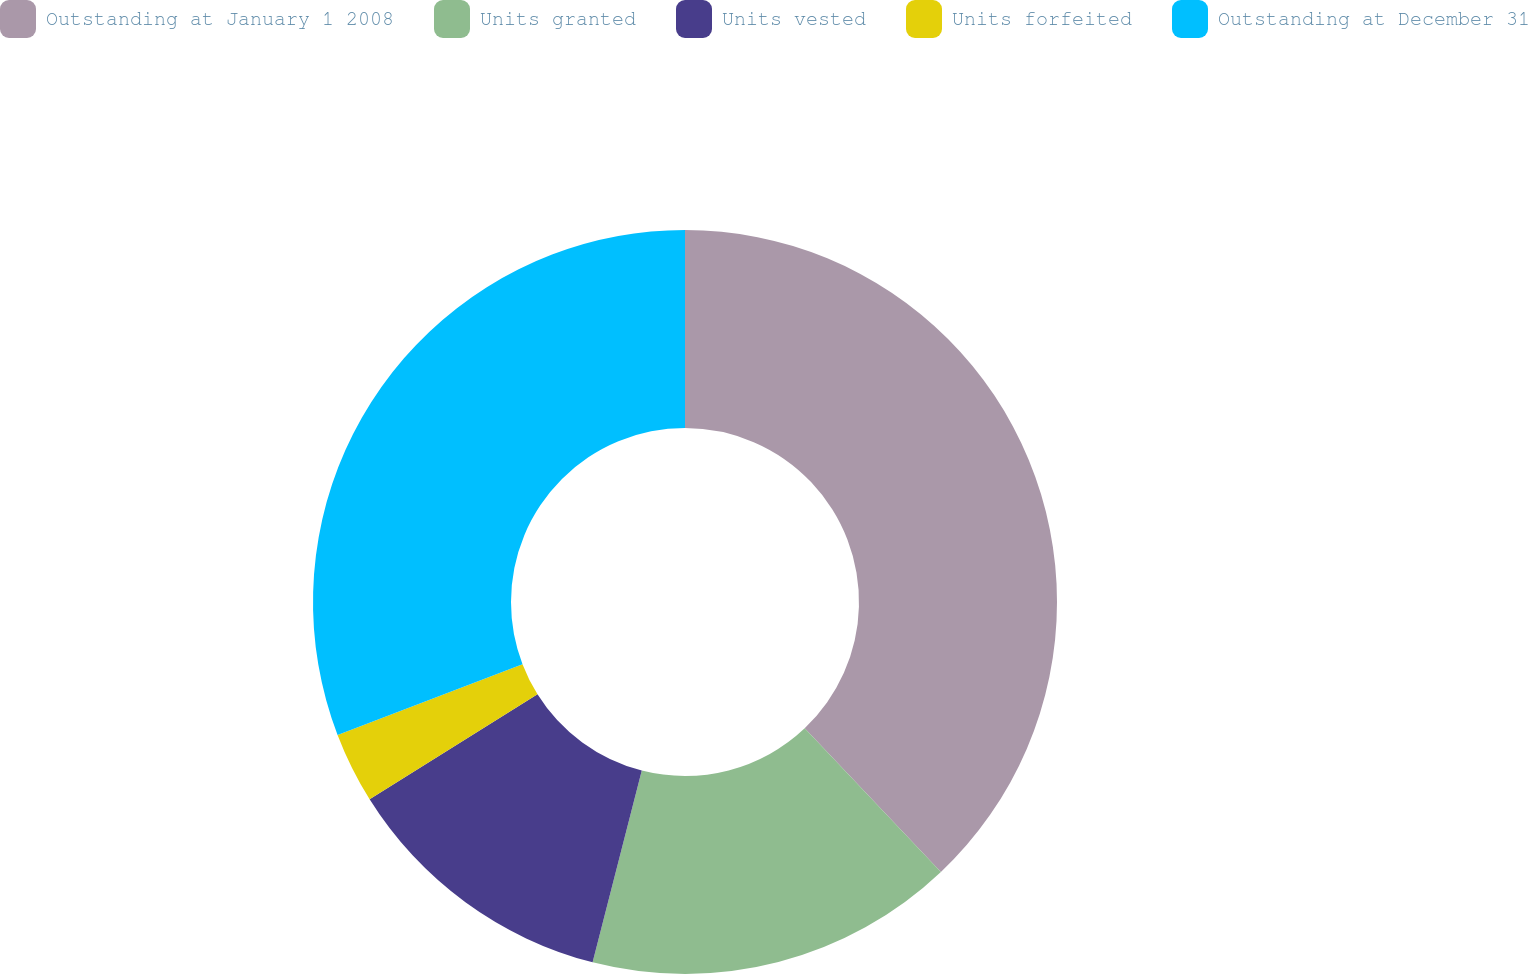<chart> <loc_0><loc_0><loc_500><loc_500><pie_chart><fcel>Outstanding at January 1 2008<fcel>Units granted<fcel>Units vested<fcel>Units forfeited<fcel>Outstanding at December 31<nl><fcel>37.93%<fcel>16.07%<fcel>12.11%<fcel>3.08%<fcel>30.82%<nl></chart> 